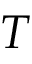<formula> <loc_0><loc_0><loc_500><loc_500>T</formula> 